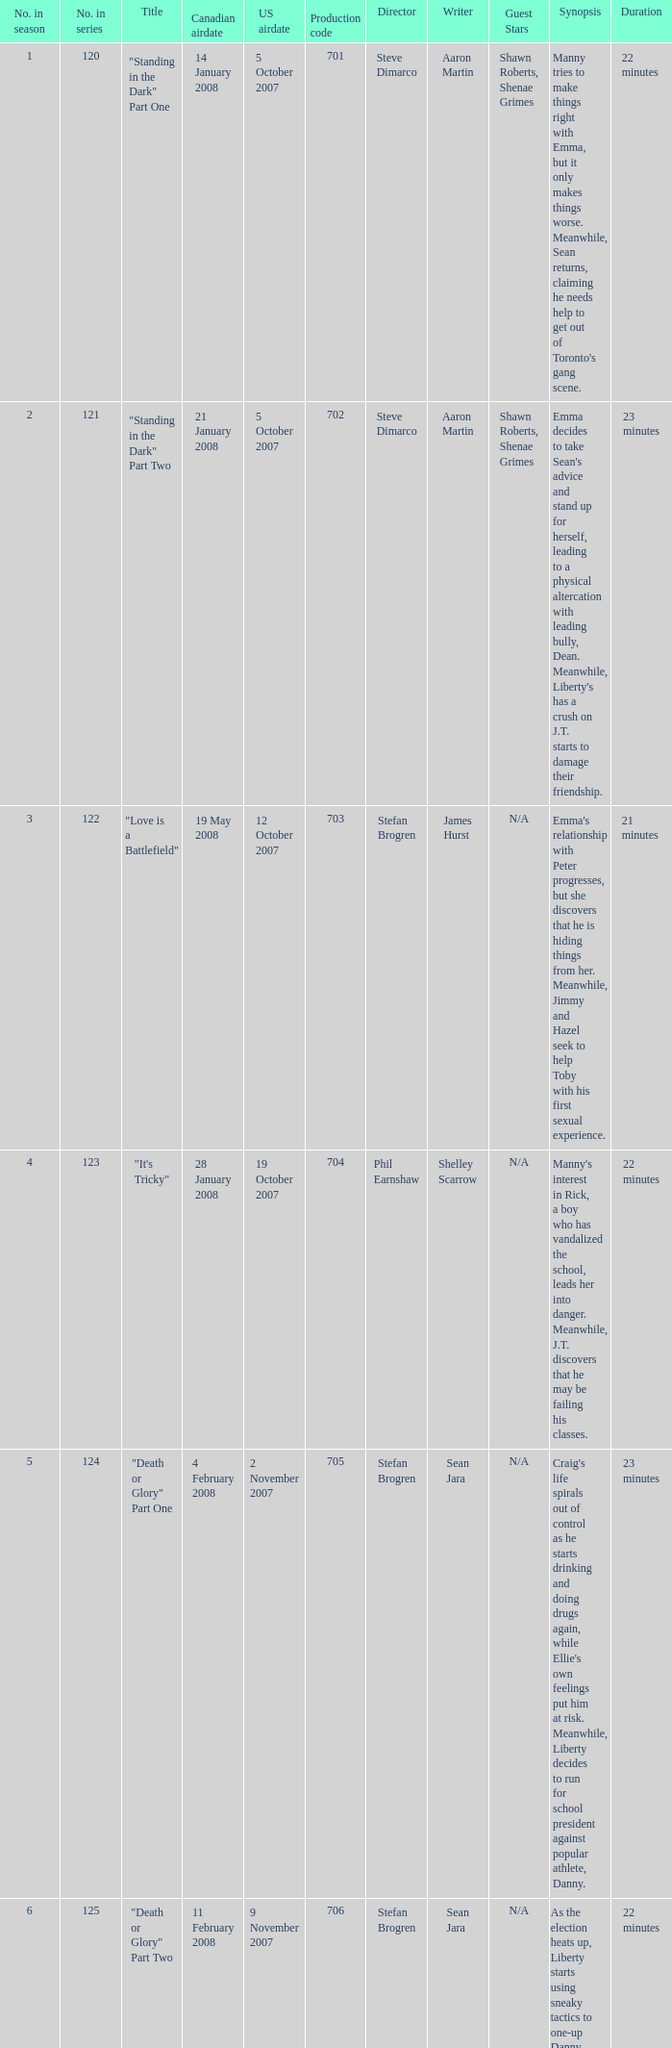The canadian airdate of 17 march 2008 had how many numbers in the season? 1.0. Could you help me parse every detail presented in this table? {'header': ['No. in season', 'No. in series', 'Title', 'Canadian airdate', 'US airdate', 'Production code', 'Director', 'Writer', 'Guest Stars', 'Synopsis', 'Duration'], 'rows': [['1', '120', '"Standing in the Dark" Part One', '14 January 2008', '5 October 2007', '701', 'Steve Dimarco', 'Aaron Martin', 'Shawn Roberts, Shenae Grimes', "Manny tries to make things right with Emma, but it only makes things worse. Meanwhile, Sean returns, claiming he needs help to get out of Toronto's gang scene.", '22 minutes '], ['2', '121', '"Standing in the Dark" Part Two', '21 January 2008', '5 October 2007', '702', 'Steve Dimarco', 'Aaron Martin', 'Shawn Roberts, Shenae Grimes', "Emma decides to take Sean's advice and stand up for herself, leading to a physical altercation with leading bully, Dean. Meanwhile, Liberty's has a crush on J.T. starts to damage their friendship.", '23 minutes'], ['3', '122', '"Love is a Battlefield"', '19 May 2008', '12 October 2007', '703', 'Stefan Brogren', 'James Hurst', 'N/A', "Emma's relationship with Peter progresses, but she discovers that he is hiding things from her. Meanwhile, Jimmy and Hazel seek to help Toby with his first sexual experience.", '21 minutes '], ['4', '123', '"It\'s Tricky"', '28 January 2008', '19 October 2007', '704', 'Phil Earnshaw', 'Shelley Scarrow', 'N/A', "Manny's interest in Rick, a boy who has vandalized the school, leads her into danger. Meanwhile, J.T. discovers that he may be failing his classes.", '22 minutes'], ['5', '124', '"Death or Glory" Part One', '4 February 2008', '2 November 2007', '705', 'Stefan Brogren', 'Sean Jara', 'N/A', "Craig's life spirals out of control as he starts drinking and doing drugs again, while Ellie's own feelings put him at risk. Meanwhile, Liberty decides to run for school president against popular athlete, Danny.", '23 minutes'], ['6', '125', '"Death or Glory" Part Two', '11 February 2008', '9 November 2007', '706', 'Stefan Brogren', 'Sean Jara', 'N/A', "As the election heats up, Liberty starts using sneaky tactics to one-up Danny, while Craig and Ellie's relationship becomes more complicated.", '22 minutes'], ['7', '126', '"We Got the Beat"', '18 February 2008', '16 November 2007', '707', 'Stefan Brogren', 'Duana Taha', 'N/A', "Paige discovers a love of playing the drums, while Peter's presence starts to tear apart the band. Meanwhile, Alex's strained relationship with her mother worsens.", '23 minutes'], ['8', '127', '"Jessie\'s Girl"', '25 February 2008', '8 February 2008', '708', 'Stefan Brogren', 'Sean Carley', 'N/A', "Spinner convinces Jimmy to join him at a strip club, leading to unexpected consequences. Meanwhile, Peter's relationship with Emma is tested when he shares interest in music with Manny.", '21 minutes '], ['9', '128', '"Hungry Eyes"', '3 March 2008', '15 February 2008', '709', 'Stefan Brogren', 'James Hurst', 'N/A', "Toby's love life gets complicated when he discovers that both his girlfriend and his crush are keeping secrets from him. Meanwhile, Spinner tries to get his driver's license but struggles to do so.", '22 minutes'], ['10', '129', '"Pass the Dutchie"', '10 March 2008', '22 February 2008', '710', 'Stefan Brogren', 'Aaron Martin', 'N/A', "Jimmy invites the people involved in Rick's shooting to a gathering to talk about the incident, leading to unexpected confrontations. Meanwhile, Spinner and Marco's friendship is tested when Marco starts dating Dylan, the new boy at school.", '23 minutes'], ['11', '130', '"Owner of a Lonely Heart"', '17 March 2008', '29 February 2008', '711', 'Stefan Brogren', 'Sean Reycraft', 'N/A', 'Ellie seeks comfort in a relationship with Marco, but her feelings for Craig and her self-doubt might ruin it. Meanwhile, Jimmy has to deal with the aftermath of his fight with Spinner.', '22 minutes'], ['12', '131', '"Live to Tell"', '24 March 2008', '7 March 2008', '712', 'Stefan Brogren', 'Shelley Scarrow', 'N/A', "Emma's new video project exposes secrets about relationships and sex that most would rather keep hidden. Meanwhile, Paige's unresolved feelings for a former girlfriend complicate her relationship with Alex.", '23 minutes'], ['13', '132', '"Bust a Move" Part One', '31 March 2008', '4 April 2008', '713', 'Stefan Brogren', 'Yan Moore', 'Cassie Steele, Lauren Collins, Jake Epstein', 'Jay and Spinner\'s business selling "Spinner-Approved" lunches becomes a success but puts them into conflict with the school administration. Meanwhile, the school plays host to the national cheerleading championships, and Liberty becomes the captain of the cheerleading squad.', '22 minutes '], ['14', '133', '"Bust a Move" Part Two', '7 April 2008', '4 April 2008', '714', 'Stefan Brogren', 'Yan Moore', 'Cassie Steele, Lauren Collins, Jake Epstein', 'The end of the year is approaching, and the students of Degrassi Street have to put up with final exams, prom, and graduation. Meanwhile, Ellie tries to convince Marco to come out to his mother, and Liberty struggles to find a date for prom.', '23 minutes '], ['15', '134', '"Got My Mind Set on You"', '14 April 2008', '11 April 2008', '715', 'Stefan Brogren', 'Sean Reycraft', 'N/A', "Spinner and Jane's relationship is tested when Jane is caught cheating on a test. Meanwhile, Holly J. and Anya's friendship threatens to end due to uncertain circumstances.", '22 minutes '], ['16', '135', '"Sweet Child o\' Mine"', '21 April 2008', '18 April 2008', '716', 'Sean Mc Carthy', 'James Hurst', 'N/A', "When the school hosts a Battle of the Bands competition, rivalries both new and old flare up, and relationships are put to the test. Meanwhile, Sav tries to win over Anya's family to gain their approval.", '23 minutes '], ['17', '136', '"Talking in Your Sleep"', '28 April 2008', '9 May 2008', '717', 'Stefan Brogren', 'Duana Taha', 'N/A', 'Jane starts acting differently after being dumped by Spinner, causing everyone to worry about her behavior. Meanwhile, Holly J. tries to gain popularity by using Anya as her guinea pig.', '22 minutes'], ['18', '137', '"Another Brick in the Wall"', '5 May 2008', '25 April 2008', '718', 'Stefan Brogren', 'Michael Grassi', 'N/A', "Ellie gets assigned to work with Marco on a project about breast cancer. Meanwhile, Declan's arrival at Degrassi makes Fiona question her own identity and her relationship with Bobby.", '23 minutes'], ['19', '138', '"Broken Wings"', '12 May 2008', '11 July 2008', '719', 'Stefan Brogren', 'James Hurst', 'N/A', "When the band goes on a trip to New York, Peter's ego starts to get out of control. Meanwhile, Paige and Alex's relationship is tested by Alex's aloofness and Paige's insecurities.", '22 minutes '], ['20', '139', '"Ladies\' Night"', '26 May 2008', '18 July 2008', '720', 'Phil Earnshaw', 'Sean Carley', 'N/A', 'Chantay tries to impress Danny by becoming a "bad girl", but it leads to unexpected consequences. Meanwhile, Holly J. and Jane\'s friendship is tested when Jane starts hanging out with the popular girls.', '23 minutes '], ['21', '140', '"Everything She Wants"', '2 June 2008', '11 July 2008', '721', 'Stefan Brogren', 'Mike Moore', 'N/A', "Mia struggles to balance modeling and being a single mother, and her decision to quit school angers Anya. Meanwhile, Sav tries to reconcile his affection for his sister's best friend, Anya, with his devout Muslim faith.", '22 minutes '], ['22', '141', '"Don\'t Stop Believin\'"', '9 June 2008', '25 July 2008', '722', 'Stefan Brogren', 'James Hurst', 'N/A', 'Emma tries to convince Manny that she should take her time in deciding on colleges. Meanwhile, Holly J. and Anya try to one-up each other with their prom dresses.', '23 minutes '], ['23', '142', '"If This Is It"', '16 June 2008', '8 August 2008', '723', 'Stefan Brogren', 'Tassie Cameron', 'N/A', "Paige thinks that she has the perfect end of high school experience planned, but everything goes awry. Meanwhile, Marco's graduation is bittersweet, his future with Dylan uncertain.", '22 minutes']]} 